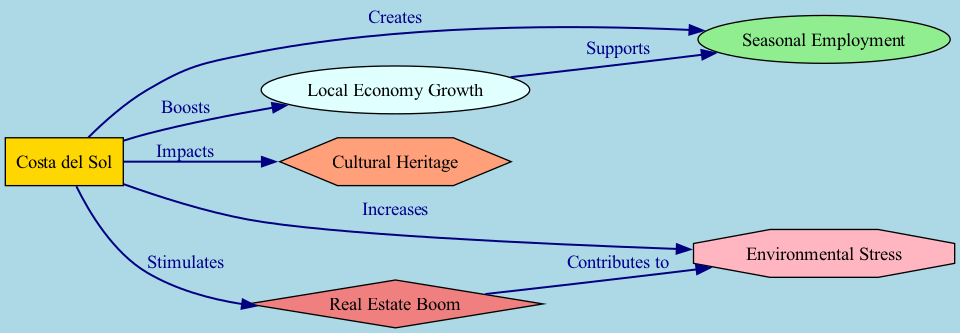What is the main location represented in the diagram? The diagram shows "Costa del Sol" as the central node, indicating that it is the primary location being discussed regarding tourism impacts.
Answer: Costa del Sol How many nodes are present in the diagram? By counting the unique items listed under the "nodes" section, it can be determined that there are six nodes in total.
Answer: 6 What relationship exists between "Costa del Sol" and "Seasonal Employment"? The diagram indicates that "Costa del Sol" creates "Seasonal Employment," which means there is a direct influence from the location to this type of employment.
Answer: Creates Which node is influenced by both "Costa del Sol" and "Real Estate Boom"? Upon examining the edges, "Environmental Stress" is linked to "Costa del Sol" and is also contributed to by "Real Estate Boom," showing a dual influence from these nodes.
Answer: Environmental Stress How does "Local Economy Growth" relate to "Seasonal Employment"? The connection shows that "Local Economy Growth" supports "Seasonal Employment," indicating that an increase in the local economy has a positive impact on the availability of seasonal jobs.
Answer: Supports What is the nature of the connection between "Real Estate Boom" and "Environmental Stress"? The diagram illustrates that "Real Estate Boom" contributes to "Environmental Stress," indicating that the rise in real estate activity can lead to more environmental pressure.
Answer: Contributes to How is "Cultural Heritage" affected by "Costa del Sol"? The diagram states that "Costa del Sol" impacts "Cultural Heritage," suggesting that tourism activities in the region can influence the preservation or alteration of local culture.
Answer: Impacts What effect does tourism in "Costa del Sol" have on the local economy? The diagram shows that "Costa del Sol" boosts "Local Economy Growth," meaning that tourism is a significant driver of economic advancement in that area.
Answer: Boosts What type of job opportunities are mentioned in the diagram related to tourism? The diagram specifies "Seasonal Employment" as a direct outcome of tourism activities, highlighting the temporary nature of some job opportunities in the region.
Answer: Seasonal Employment 